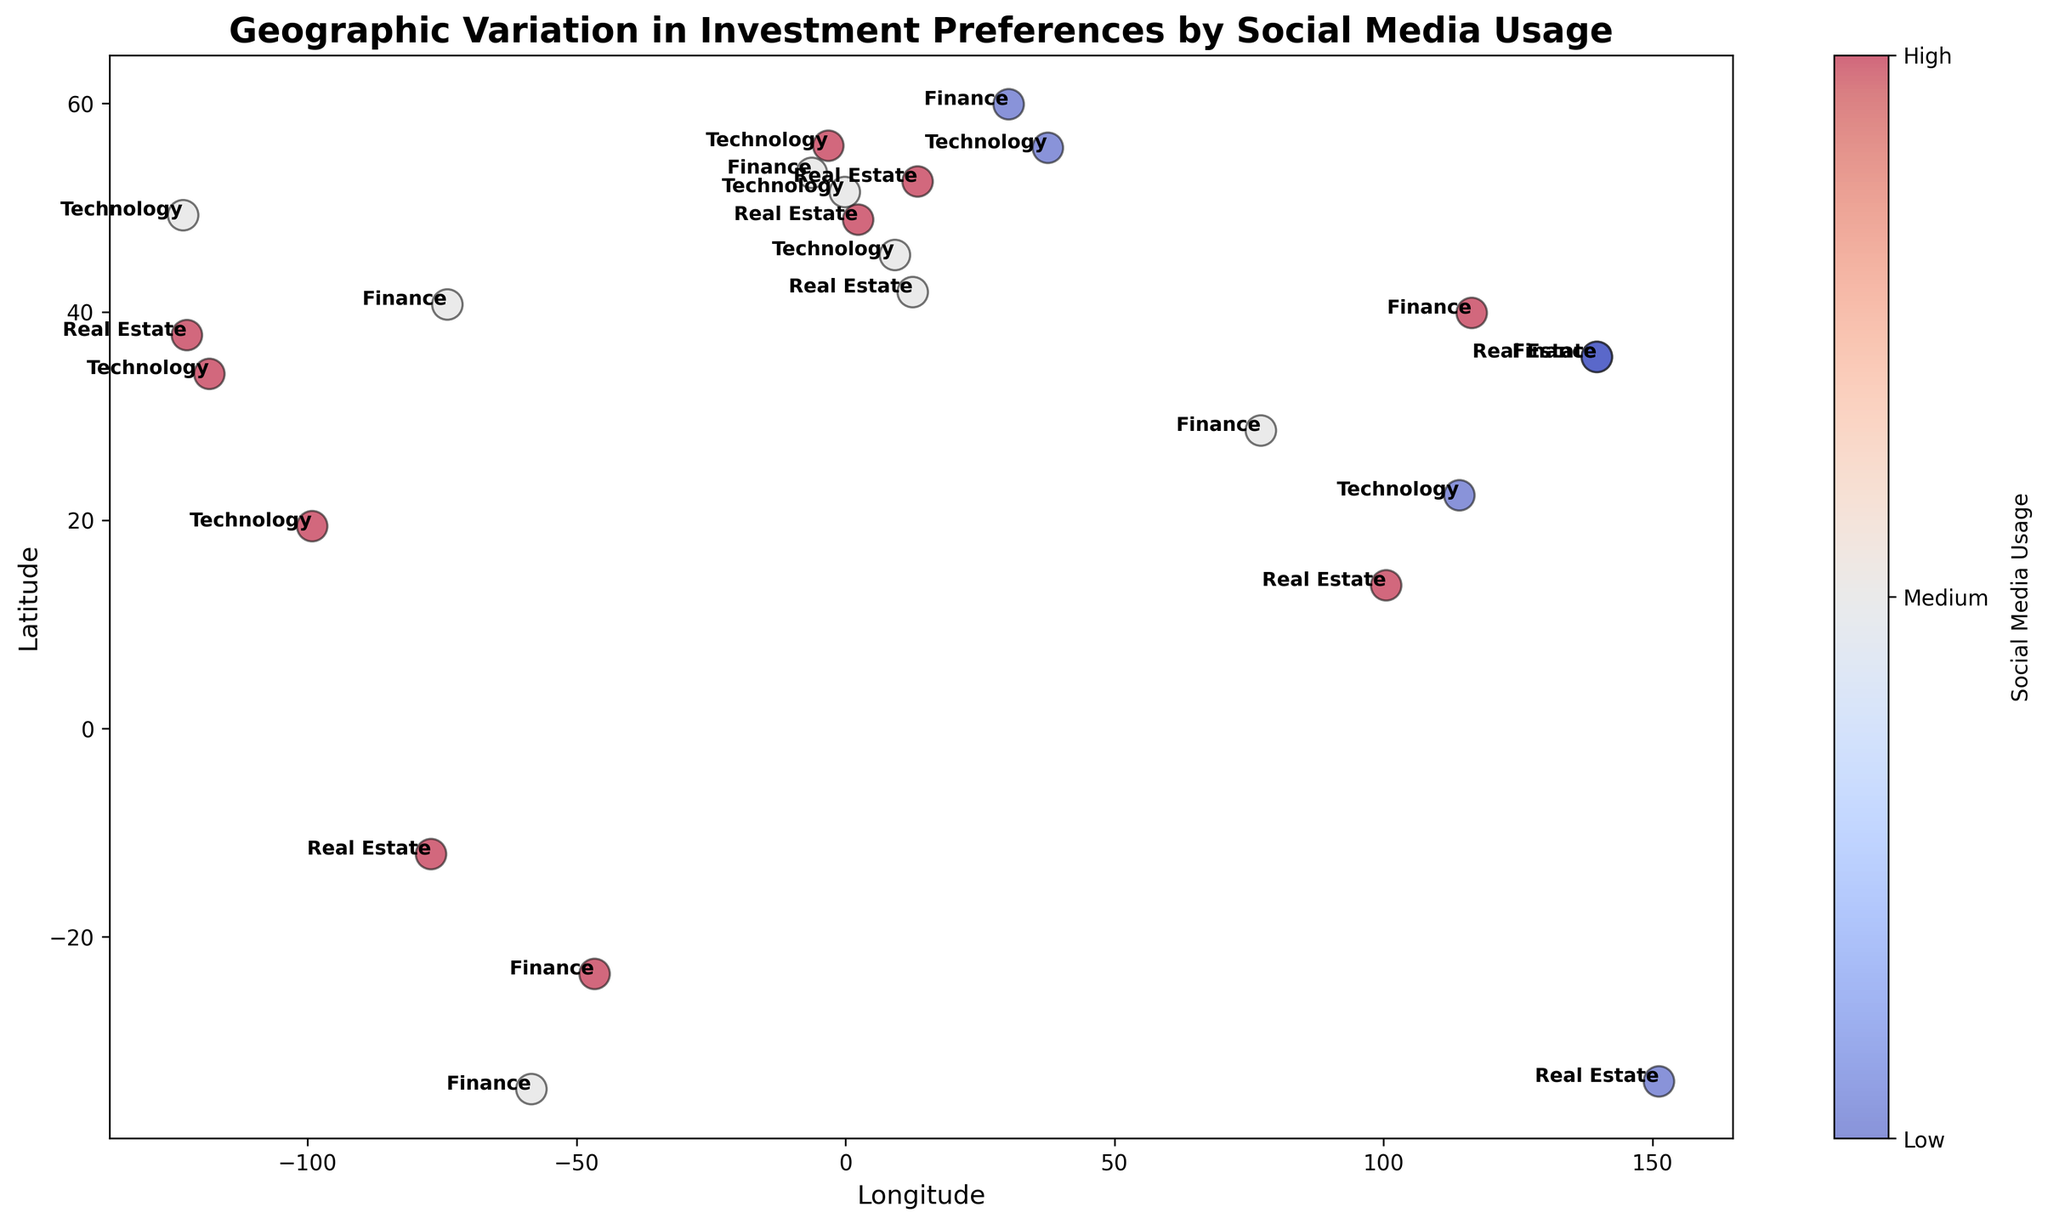What regions have a high social media usage and a preference for Technology investments? We look at data points colored with the highest intensity of red for social media usage and labeled with 'Technology' for investment preference. The regions include Los Angeles (34.0522, -118.2437), Mexico City (19.4336, -99.1332), and Edinburgh (55.9533, -3.1883).
Answer: Los Angeles, Mexico City, Edinburgh What investment preference is associated with high social media usage in Paris? In Paris, the point is labeled 'Real Estate' and colored with the highest intensity of red.
Answer: Real Estate Which region has a medium social media usage and a preference for Finance investments? We look at points colored with medium intensity red and labeled 'Finance'. The regions include New York (40.7128, -74.006), New Delhi (28.6139, 77.209), Dublin (53.3498, -6.2603), and Buenos Aires (34.6037, -58.3816).
Answer: New York, New Delhi, Dublin, Buenos Aires What is the social media usage level for Tokyo's Finance investment preference? In Tokyo (35.6895, 139.6917), the point labeled 'Finance' is colored with the lowest intensity of red.
Answer: Low Among all regions with a preference for Real Estate, which ones have high social media usage? We look at regions labeled 'Real Estate' and select those with the highest intensity of red. These regions are San Francisco (37.7749, -122.4194), Paris (48.8566, 2.3522), and Lima (12.0464, -77.0428).
Answer: San Francisco, Paris, Lima What color is associated with medium social media usage, and which cities have this classification? Medium social media usage is associated with a medium intensity of red. The cities include New York, London (51.5074, -0.1278), Rome (41.9028, 12.4964), New Delhi, Vancouver (49.2827, -123.1207), Milan (45.4642, 9.1900), Dublin, Buenos Aires
Answer: New York, London, Rome, New Delhi, Vancouver, Milan, Dublin, Buenos Aires Which city is at latitude 55.7558 and what is its investment preference and social media usage level? The city is Moscow (55.7558, 37.6176). Its investment preference is Technology, and the social media usage is low (indicated by the lowest intensity of red).
Answer: Moscow, Technology, Low How many cities have high social media usage for Finance investments? We identify Finance investments colored with the highest intensity of red and count them. The cities fulfilling these criteria are Beijing (39.9042, 116.4074) and São Paulo (23.5505, -46.6333).
Answer: 2 